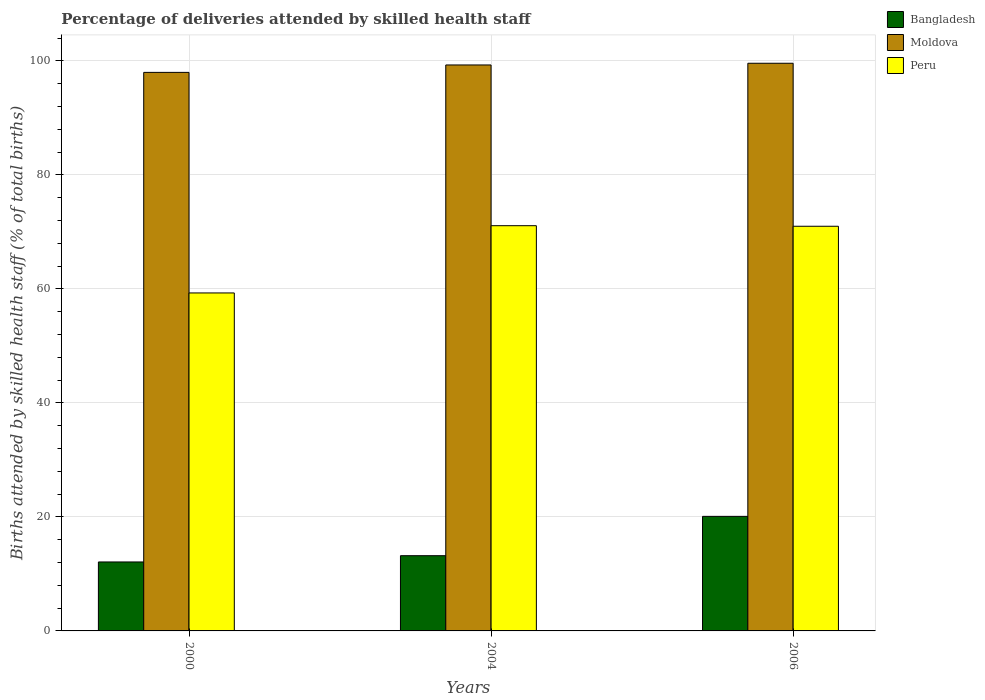How many different coloured bars are there?
Offer a very short reply. 3. How many groups of bars are there?
Give a very brief answer. 3. Are the number of bars per tick equal to the number of legend labels?
Ensure brevity in your answer.  Yes. Are the number of bars on each tick of the X-axis equal?
Your answer should be compact. Yes. What is the label of the 2nd group of bars from the left?
Make the answer very short. 2004. In how many cases, is the number of bars for a given year not equal to the number of legend labels?
Ensure brevity in your answer.  0. What is the percentage of births attended by skilled health staff in Peru in 2004?
Provide a short and direct response. 71.1. Across all years, what is the maximum percentage of births attended by skilled health staff in Peru?
Provide a short and direct response. 71.1. Across all years, what is the minimum percentage of births attended by skilled health staff in Peru?
Provide a short and direct response. 59.3. In which year was the percentage of births attended by skilled health staff in Bangladesh maximum?
Provide a succinct answer. 2006. What is the total percentage of births attended by skilled health staff in Peru in the graph?
Offer a terse response. 201.4. What is the difference between the percentage of births attended by skilled health staff in Moldova in 2000 and that in 2004?
Offer a terse response. -1.3. What is the difference between the percentage of births attended by skilled health staff in Moldova in 2000 and the percentage of births attended by skilled health staff in Bangladesh in 2006?
Ensure brevity in your answer.  77.9. What is the average percentage of births attended by skilled health staff in Peru per year?
Ensure brevity in your answer.  67.13. In the year 2006, what is the difference between the percentage of births attended by skilled health staff in Peru and percentage of births attended by skilled health staff in Moldova?
Provide a short and direct response. -28.6. In how many years, is the percentage of births attended by skilled health staff in Bangladesh greater than 92 %?
Offer a very short reply. 0. What is the ratio of the percentage of births attended by skilled health staff in Moldova in 2000 to that in 2004?
Make the answer very short. 0.99. Is the difference between the percentage of births attended by skilled health staff in Peru in 2000 and 2006 greater than the difference between the percentage of births attended by skilled health staff in Moldova in 2000 and 2006?
Make the answer very short. No. What is the difference between the highest and the second highest percentage of births attended by skilled health staff in Moldova?
Ensure brevity in your answer.  0.3. What is the difference between the highest and the lowest percentage of births attended by skilled health staff in Bangladesh?
Offer a terse response. 8. In how many years, is the percentage of births attended by skilled health staff in Moldova greater than the average percentage of births attended by skilled health staff in Moldova taken over all years?
Your answer should be very brief. 2. What does the 3rd bar from the right in 2004 represents?
Offer a terse response. Bangladesh. How many bars are there?
Offer a very short reply. 9. What is the difference between two consecutive major ticks on the Y-axis?
Offer a very short reply. 20. Are the values on the major ticks of Y-axis written in scientific E-notation?
Ensure brevity in your answer.  No. How many legend labels are there?
Your response must be concise. 3. How are the legend labels stacked?
Make the answer very short. Vertical. What is the title of the graph?
Ensure brevity in your answer.  Percentage of deliveries attended by skilled health staff. Does "High income: OECD" appear as one of the legend labels in the graph?
Offer a very short reply. No. What is the label or title of the X-axis?
Offer a terse response. Years. What is the label or title of the Y-axis?
Your answer should be very brief. Births attended by skilled health staff (% of total births). What is the Births attended by skilled health staff (% of total births) in Bangladesh in 2000?
Provide a short and direct response. 12.1. What is the Births attended by skilled health staff (% of total births) of Moldova in 2000?
Your answer should be very brief. 98. What is the Births attended by skilled health staff (% of total births) of Peru in 2000?
Keep it short and to the point. 59.3. What is the Births attended by skilled health staff (% of total births) in Moldova in 2004?
Ensure brevity in your answer.  99.3. What is the Births attended by skilled health staff (% of total births) in Peru in 2004?
Keep it short and to the point. 71.1. What is the Births attended by skilled health staff (% of total births) in Bangladesh in 2006?
Offer a terse response. 20.1. What is the Births attended by skilled health staff (% of total births) of Moldova in 2006?
Ensure brevity in your answer.  99.6. What is the Births attended by skilled health staff (% of total births) of Peru in 2006?
Your answer should be compact. 71. Across all years, what is the maximum Births attended by skilled health staff (% of total births) in Bangladesh?
Provide a succinct answer. 20.1. Across all years, what is the maximum Births attended by skilled health staff (% of total births) in Moldova?
Offer a very short reply. 99.6. Across all years, what is the maximum Births attended by skilled health staff (% of total births) of Peru?
Provide a short and direct response. 71.1. Across all years, what is the minimum Births attended by skilled health staff (% of total births) in Bangladesh?
Make the answer very short. 12.1. Across all years, what is the minimum Births attended by skilled health staff (% of total births) of Moldova?
Ensure brevity in your answer.  98. Across all years, what is the minimum Births attended by skilled health staff (% of total births) in Peru?
Your response must be concise. 59.3. What is the total Births attended by skilled health staff (% of total births) in Bangladesh in the graph?
Your response must be concise. 45.4. What is the total Births attended by skilled health staff (% of total births) in Moldova in the graph?
Ensure brevity in your answer.  296.9. What is the total Births attended by skilled health staff (% of total births) of Peru in the graph?
Offer a terse response. 201.4. What is the difference between the Births attended by skilled health staff (% of total births) of Moldova in 2000 and that in 2004?
Make the answer very short. -1.3. What is the difference between the Births attended by skilled health staff (% of total births) of Bangladesh in 2000 and that in 2006?
Make the answer very short. -8. What is the difference between the Births attended by skilled health staff (% of total births) of Moldova in 2000 and that in 2006?
Offer a terse response. -1.6. What is the difference between the Births attended by skilled health staff (% of total births) of Bangladesh in 2004 and that in 2006?
Ensure brevity in your answer.  -6.9. What is the difference between the Births attended by skilled health staff (% of total births) of Moldova in 2004 and that in 2006?
Offer a terse response. -0.3. What is the difference between the Births attended by skilled health staff (% of total births) of Bangladesh in 2000 and the Births attended by skilled health staff (% of total births) of Moldova in 2004?
Your answer should be very brief. -87.2. What is the difference between the Births attended by skilled health staff (% of total births) of Bangladesh in 2000 and the Births attended by skilled health staff (% of total births) of Peru in 2004?
Offer a terse response. -59. What is the difference between the Births attended by skilled health staff (% of total births) in Moldova in 2000 and the Births attended by skilled health staff (% of total births) in Peru in 2004?
Make the answer very short. 26.9. What is the difference between the Births attended by skilled health staff (% of total births) in Bangladesh in 2000 and the Births attended by skilled health staff (% of total births) in Moldova in 2006?
Your response must be concise. -87.5. What is the difference between the Births attended by skilled health staff (% of total births) of Bangladesh in 2000 and the Births attended by skilled health staff (% of total births) of Peru in 2006?
Make the answer very short. -58.9. What is the difference between the Births attended by skilled health staff (% of total births) of Moldova in 2000 and the Births attended by skilled health staff (% of total births) of Peru in 2006?
Make the answer very short. 27. What is the difference between the Births attended by skilled health staff (% of total births) in Bangladesh in 2004 and the Births attended by skilled health staff (% of total births) in Moldova in 2006?
Keep it short and to the point. -86.4. What is the difference between the Births attended by skilled health staff (% of total births) of Bangladesh in 2004 and the Births attended by skilled health staff (% of total births) of Peru in 2006?
Give a very brief answer. -57.8. What is the difference between the Births attended by skilled health staff (% of total births) of Moldova in 2004 and the Births attended by skilled health staff (% of total births) of Peru in 2006?
Your answer should be compact. 28.3. What is the average Births attended by skilled health staff (% of total births) of Bangladesh per year?
Provide a succinct answer. 15.13. What is the average Births attended by skilled health staff (% of total births) in Moldova per year?
Offer a terse response. 98.97. What is the average Births attended by skilled health staff (% of total births) of Peru per year?
Give a very brief answer. 67.13. In the year 2000, what is the difference between the Births attended by skilled health staff (% of total births) of Bangladesh and Births attended by skilled health staff (% of total births) of Moldova?
Your response must be concise. -85.9. In the year 2000, what is the difference between the Births attended by skilled health staff (% of total births) in Bangladesh and Births attended by skilled health staff (% of total births) in Peru?
Make the answer very short. -47.2. In the year 2000, what is the difference between the Births attended by skilled health staff (% of total births) of Moldova and Births attended by skilled health staff (% of total births) of Peru?
Offer a terse response. 38.7. In the year 2004, what is the difference between the Births attended by skilled health staff (% of total births) of Bangladesh and Births attended by skilled health staff (% of total births) of Moldova?
Make the answer very short. -86.1. In the year 2004, what is the difference between the Births attended by skilled health staff (% of total births) of Bangladesh and Births attended by skilled health staff (% of total births) of Peru?
Give a very brief answer. -57.9. In the year 2004, what is the difference between the Births attended by skilled health staff (% of total births) in Moldova and Births attended by skilled health staff (% of total births) in Peru?
Ensure brevity in your answer.  28.2. In the year 2006, what is the difference between the Births attended by skilled health staff (% of total births) in Bangladesh and Births attended by skilled health staff (% of total births) in Moldova?
Make the answer very short. -79.5. In the year 2006, what is the difference between the Births attended by skilled health staff (% of total births) of Bangladesh and Births attended by skilled health staff (% of total births) of Peru?
Keep it short and to the point. -50.9. In the year 2006, what is the difference between the Births attended by skilled health staff (% of total births) of Moldova and Births attended by skilled health staff (% of total births) of Peru?
Offer a terse response. 28.6. What is the ratio of the Births attended by skilled health staff (% of total births) of Bangladesh in 2000 to that in 2004?
Provide a short and direct response. 0.92. What is the ratio of the Births attended by skilled health staff (% of total births) in Moldova in 2000 to that in 2004?
Keep it short and to the point. 0.99. What is the ratio of the Births attended by skilled health staff (% of total births) of Peru in 2000 to that in 2004?
Your answer should be compact. 0.83. What is the ratio of the Births attended by skilled health staff (% of total births) in Bangladesh in 2000 to that in 2006?
Keep it short and to the point. 0.6. What is the ratio of the Births attended by skilled health staff (% of total births) in Moldova in 2000 to that in 2006?
Give a very brief answer. 0.98. What is the ratio of the Births attended by skilled health staff (% of total births) in Peru in 2000 to that in 2006?
Provide a short and direct response. 0.84. What is the ratio of the Births attended by skilled health staff (% of total births) in Bangladesh in 2004 to that in 2006?
Ensure brevity in your answer.  0.66. What is the ratio of the Births attended by skilled health staff (% of total births) of Moldova in 2004 to that in 2006?
Give a very brief answer. 1. What is the difference between the highest and the second highest Births attended by skilled health staff (% of total births) of Bangladesh?
Keep it short and to the point. 6.9. What is the difference between the highest and the lowest Births attended by skilled health staff (% of total births) of Moldova?
Offer a terse response. 1.6. What is the difference between the highest and the lowest Births attended by skilled health staff (% of total births) of Peru?
Keep it short and to the point. 11.8. 